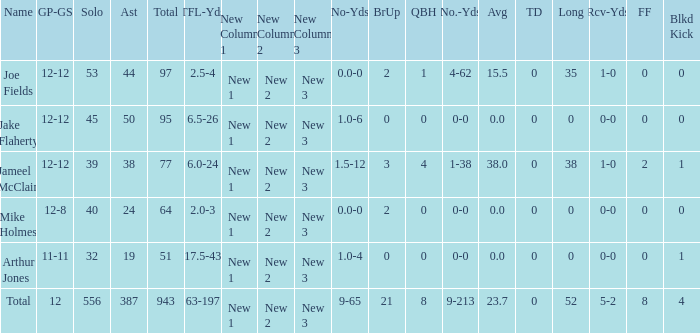What is the total brup for the team? 21.0. 